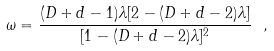Convert formula to latex. <formula><loc_0><loc_0><loc_500><loc_500>\omega = { \frac { ( D + d - 1 ) \lambda [ 2 - ( D + d - 2 ) \lambda ] } { [ 1 - ( D + d - 2 ) \lambda ] ^ { 2 } } } \ ,</formula> 